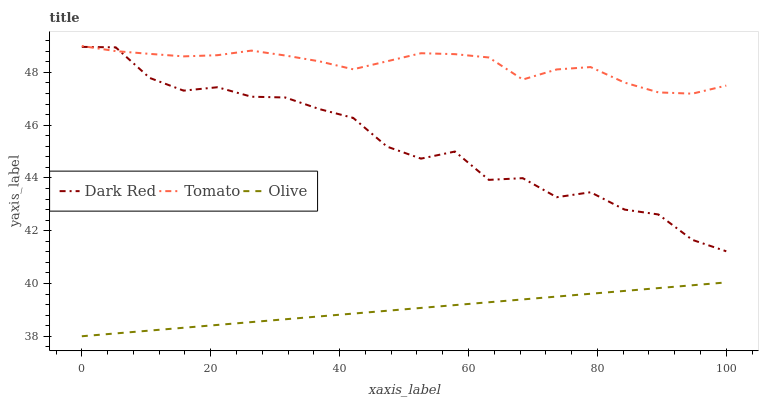Does Olive have the minimum area under the curve?
Answer yes or no. Yes. Does Tomato have the maximum area under the curve?
Answer yes or no. Yes. Does Dark Red have the minimum area under the curve?
Answer yes or no. No. Does Dark Red have the maximum area under the curve?
Answer yes or no. No. Is Olive the smoothest?
Answer yes or no. Yes. Is Dark Red the roughest?
Answer yes or no. Yes. Is Dark Red the smoothest?
Answer yes or no. No. Is Olive the roughest?
Answer yes or no. No. Does Olive have the lowest value?
Answer yes or no. Yes. Does Dark Red have the lowest value?
Answer yes or no. No. Does Tomato have the highest value?
Answer yes or no. Yes. Does Dark Red have the highest value?
Answer yes or no. No. Is Olive less than Dark Red?
Answer yes or no. Yes. Is Tomato greater than Olive?
Answer yes or no. Yes. Does Dark Red intersect Tomato?
Answer yes or no. Yes. Is Dark Red less than Tomato?
Answer yes or no. No. Is Dark Red greater than Tomato?
Answer yes or no. No. Does Olive intersect Dark Red?
Answer yes or no. No. 